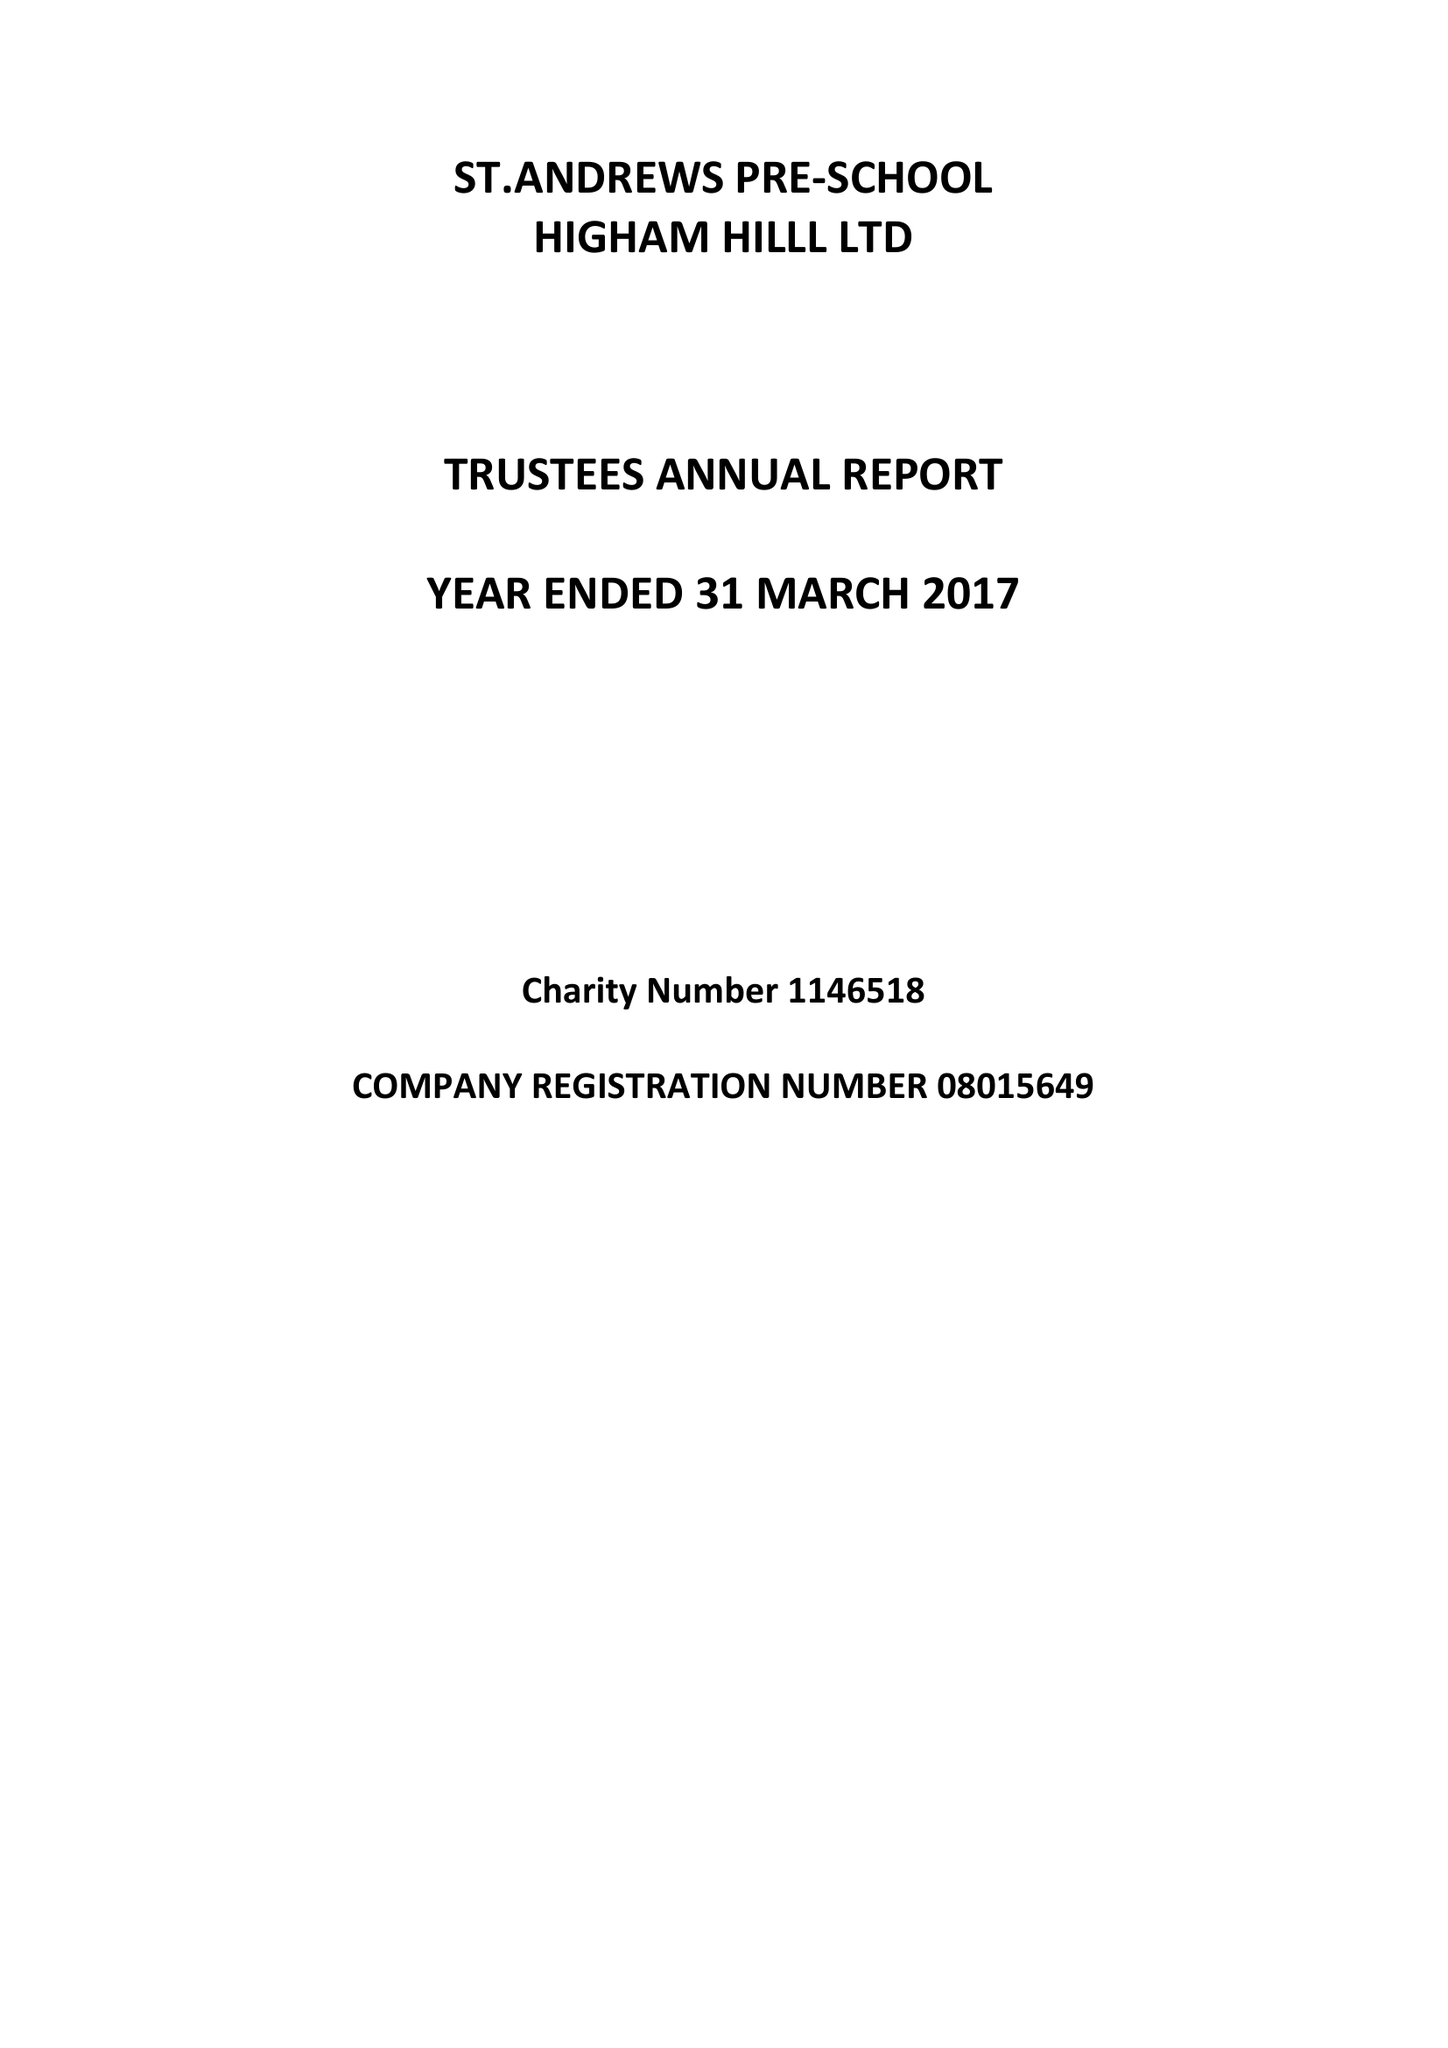What is the value for the charity_number?
Answer the question using a single word or phrase. 1146518 